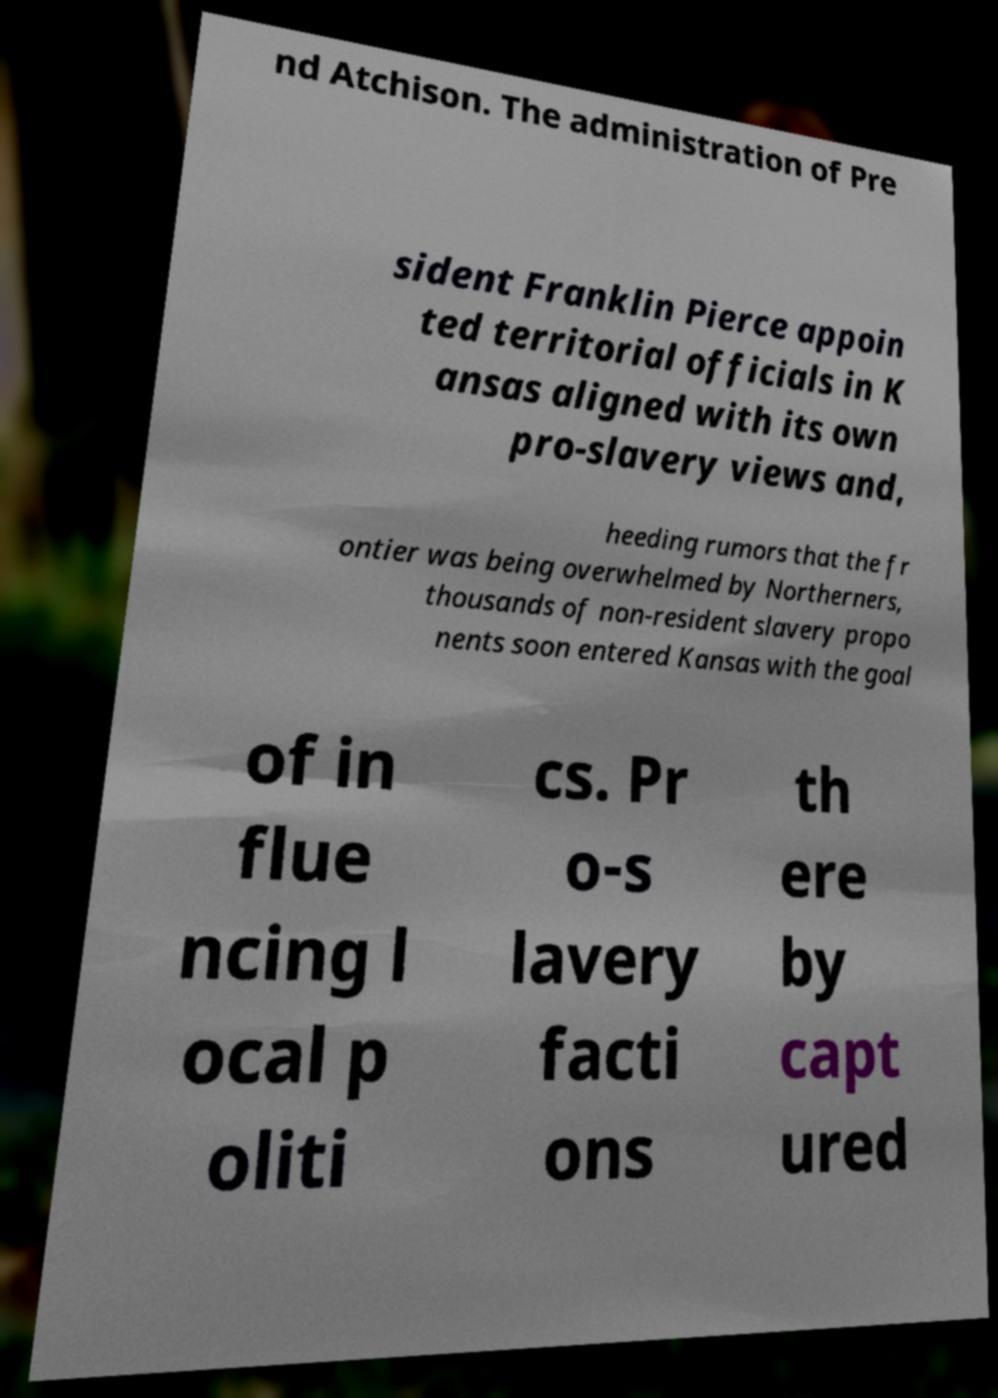Please identify and transcribe the text found in this image. nd Atchison. The administration of Pre sident Franklin Pierce appoin ted territorial officials in K ansas aligned with its own pro-slavery views and, heeding rumors that the fr ontier was being overwhelmed by Northerners, thousands of non-resident slavery propo nents soon entered Kansas with the goal of in flue ncing l ocal p oliti cs. Pr o-s lavery facti ons th ere by capt ured 